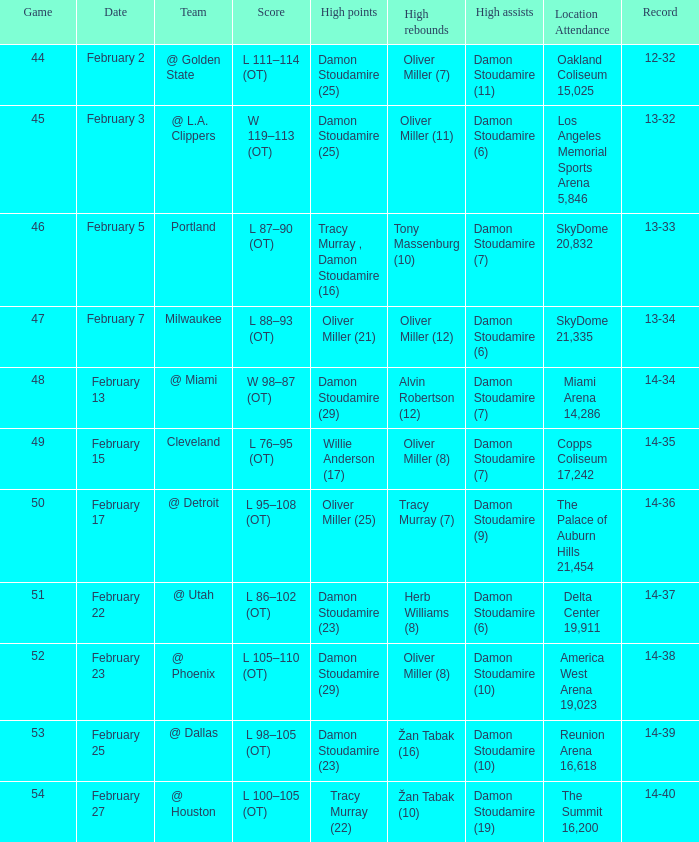How many locations have a record of 14-38? 1.0. 